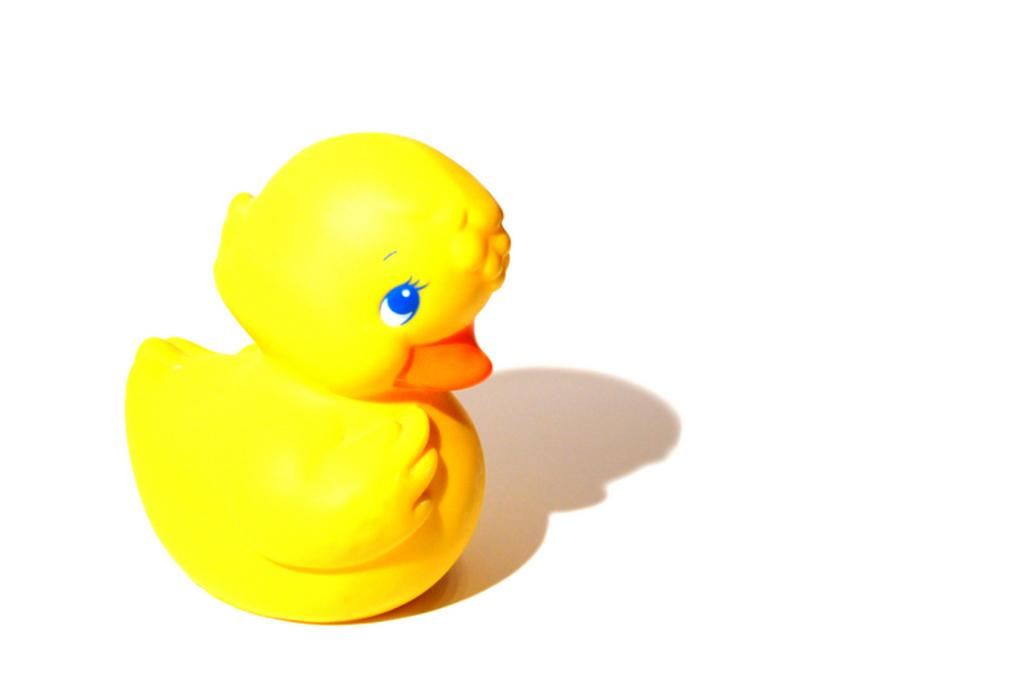What type of object is in the picture? There is a duck bath toy in the picture. What color is the duck bath toy? The duck bath toy is yellow in color. What color is the beak of the duck bath toy? The beak of the duck bath toy is orange in color. What color is the background of the image? The background of the image is white. Can you hear the parent talking to the duck bath toy in the image? There is no parent or any audible conversation in the image, as it only features a duck bath toy. 